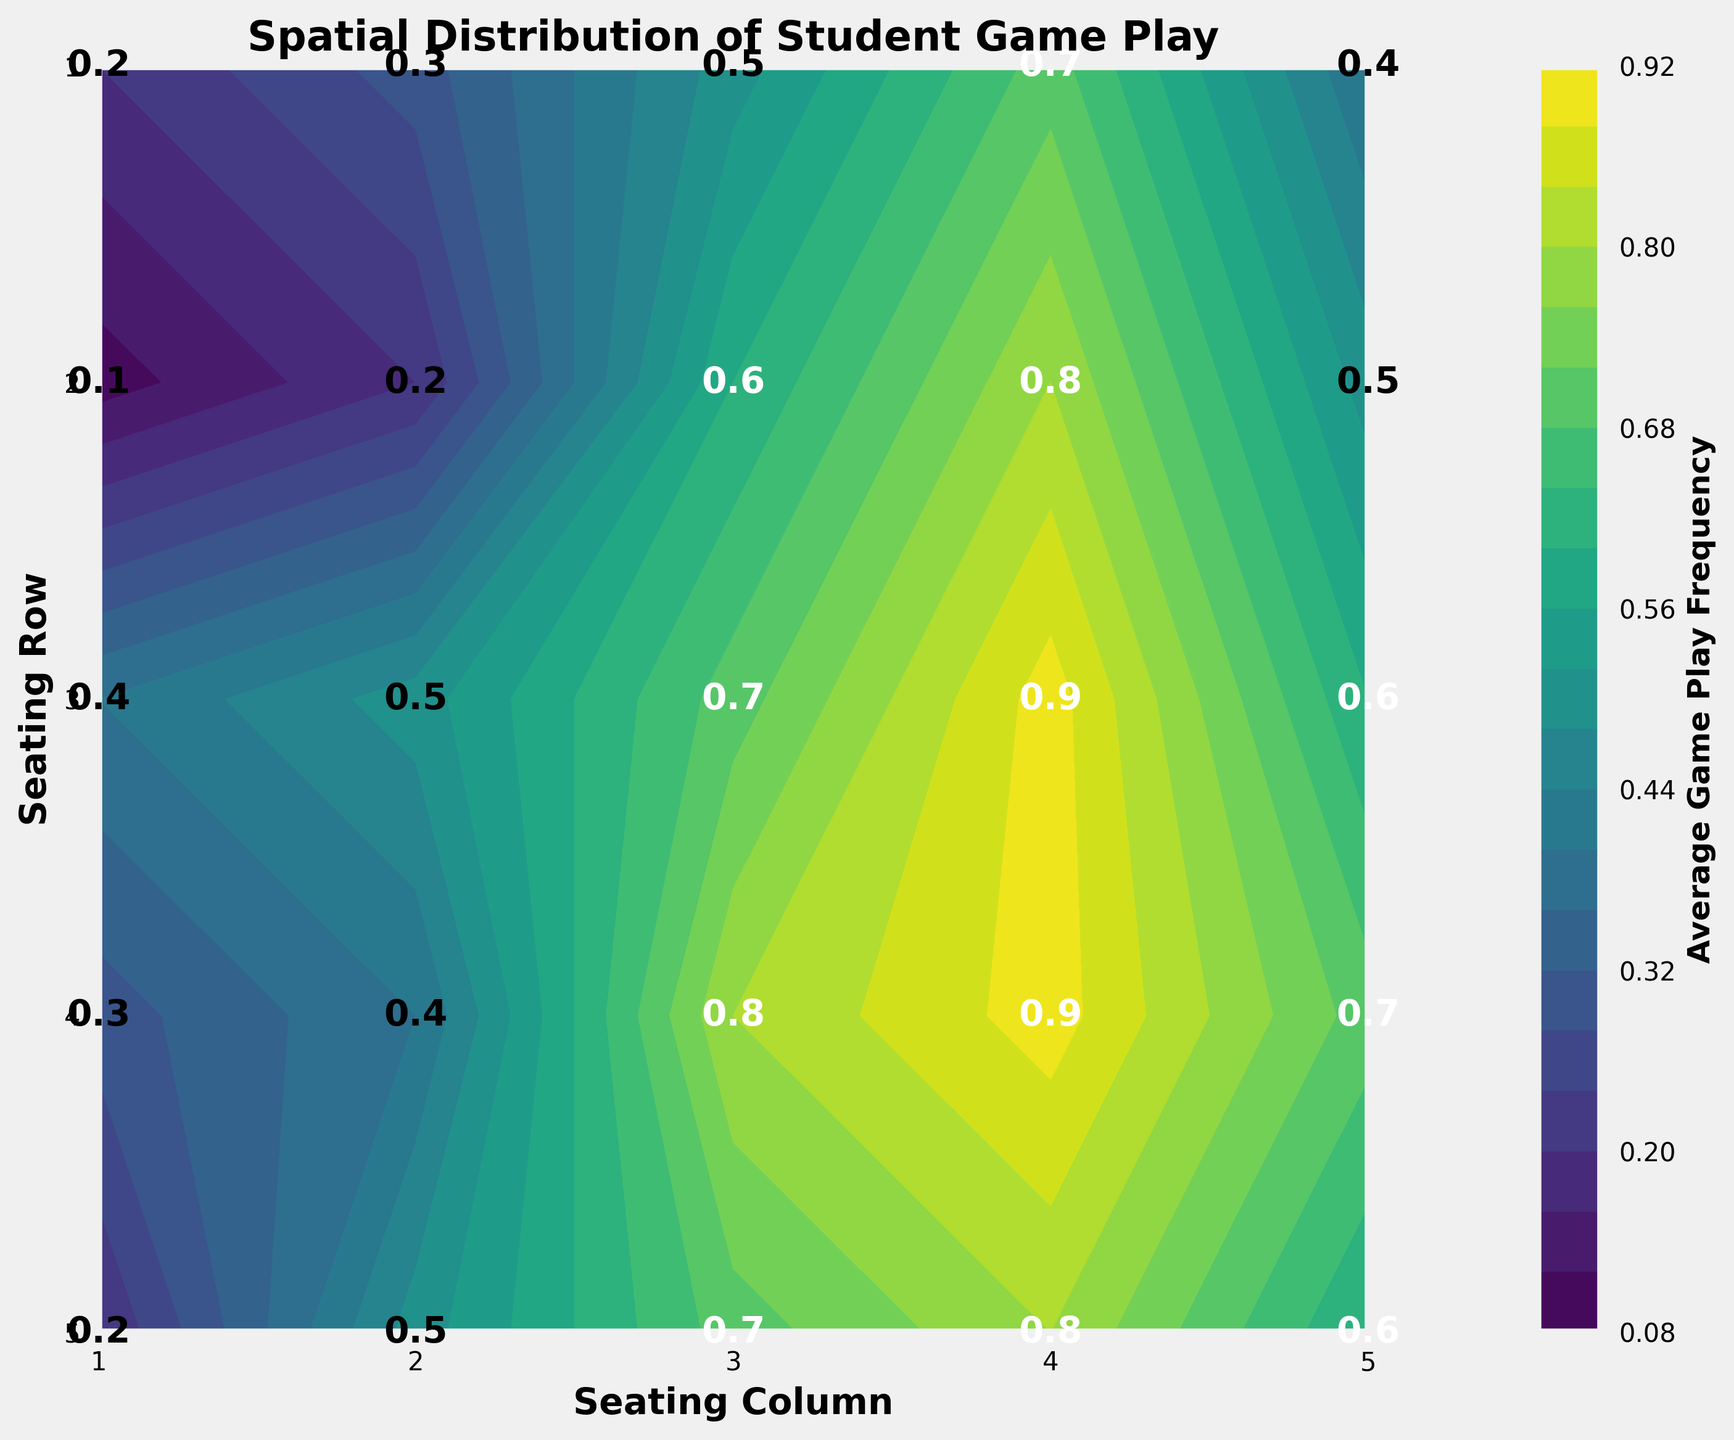What's the title of the plot? The title is usually displayed at the top of the figure, describing the main focus of the plot. Checking the top part of the figure for a bold, larger text is where the title is located. In this case, it is: "Spatial Distribution of Student Game Play".
Answer: Spatial Distribution of Student Game Play What does the color represent in the contour plot? The color in a contour plot typically represents different values of a specific variable. The color bar often details what these colors correspond to. Here, it represents the Average Game Play Frequency as indicated by the color bar label.
Answer: Average Game Play Frequency Which seating position shows the highest frequency of mobile game play? To find the highest frequency, we observe the color gradient and identify the darkest or most intense color. Also, checking the position within the contour levels can help locate this spot. For this plot, the highest value is 0.9, which is found in seating positions (3,4) and (4,4).
Answer: (3,4) and (4,4) Which seating position has the lowest frequency of mobile game play? Similar to finding the highest value, the lowest value can be seen in the lightest color or the lowest value in the contour. Checking the values in the middle of each seating position leads to the lowest frequency, which is 0.1 at (2,1).
Answer: (2,1) What is the average game play frequency for the seats in the first row? To find this, sum the game play frequencies of all the seats in the first row and then divide by the number of seats. The frequencies are 0.2, 0.3, 0.5, 0.7, and 0.4, summing up to 2.1. Dividing by 5 (the number of seats) gives 2.1/5.
Answer: 0.42 How does the frequency of game play in the back row compare to the front row? For comparison, check both rows' values. The front row's values are 0.2, 0.3, 0.5, 0.7, 0.4. The back row's values are 0.2, 0.5, 0.7, 0.8, 0.6. Clearly, the back row shows generally higher values compared to the front row.
Answer: Back row has higher frequency What is the frequency difference between seat (2,3) and seat (4,2)? Subtract the frequency of seat (4,2) from seat (2,3). The values are 0.6 and 0.4, respectively. So, 0.6 - 0.4 equals 0.2.
Answer: 0.2 Which row shows a more consistent range of game play frequency? To evaluate consistency, look at the range within each row. Row 1 ranges from 0.2 to 0.7; Row 2 from 0.1 to 0.8; Row 3 from 0.4 to 0.9; Row 4 from 0.3 to 0.9; Row 5 from 0.2 to 0.8. Row 1 has the narrowest range.
Answer: Row 1 What can you infer about the game play frequency as students sit closer to the back of the room? By observing the color intensity and values closer to the back row (especially row 4 and 5), there is an increasing trend in values, indicating higher game play frequency in the back compared to the front.
Answer: Higher in the back Can you identify any trends between seating columns and game play frequency? Checking each column's values, we can observe that columns closer to the middle (3 and 4) generally seem to have higher frequencies than the outer columns. This indicates students in the middle columns play games more frequently.
Answer: Middle columns higher 